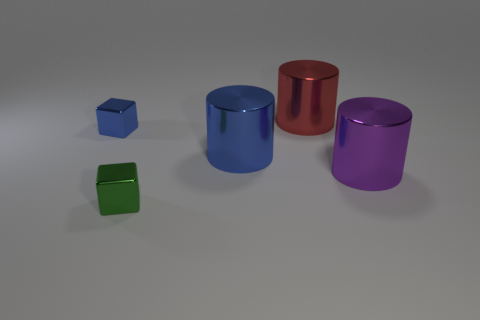Add 4 tiny metallic things. How many objects exist? 9 Subtract all big purple cylinders. How many cylinders are left? 2 Subtract all blocks. How many objects are left? 3 Subtract all blue cylinders. How many cylinders are left? 2 Subtract 1 cubes. How many cubes are left? 1 Subtract all purple blocks. Subtract all green balls. How many blocks are left? 2 Subtract all big brown metallic blocks. Subtract all metal cylinders. How many objects are left? 2 Add 2 large objects. How many large objects are left? 5 Add 3 purple shiny things. How many purple shiny things exist? 4 Subtract 0 purple cubes. How many objects are left? 5 